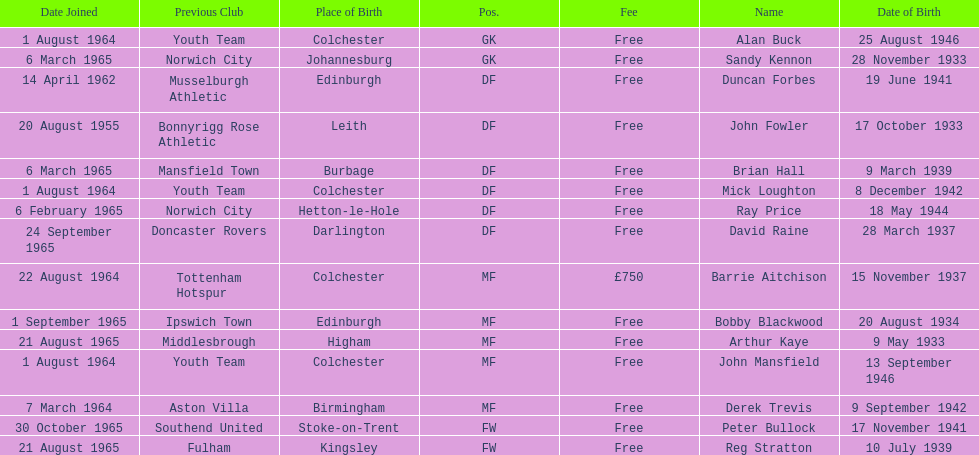Name the player whose fee was not free. Barrie Aitchison. 